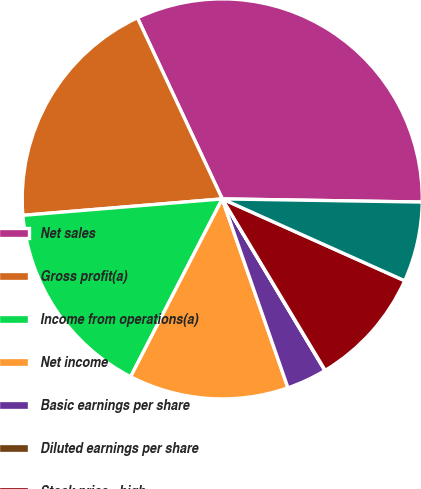Convert chart. <chart><loc_0><loc_0><loc_500><loc_500><pie_chart><fcel>Net sales<fcel>Gross profit(a)<fcel>Income from operations(a)<fcel>Net income<fcel>Basic earnings per share<fcel>Diluted earnings per share<fcel>Stock price - high<fcel>Stock price - low<nl><fcel>32.22%<fcel>19.34%<fcel>16.12%<fcel>12.9%<fcel>3.25%<fcel>0.03%<fcel>9.68%<fcel>6.46%<nl></chart> 